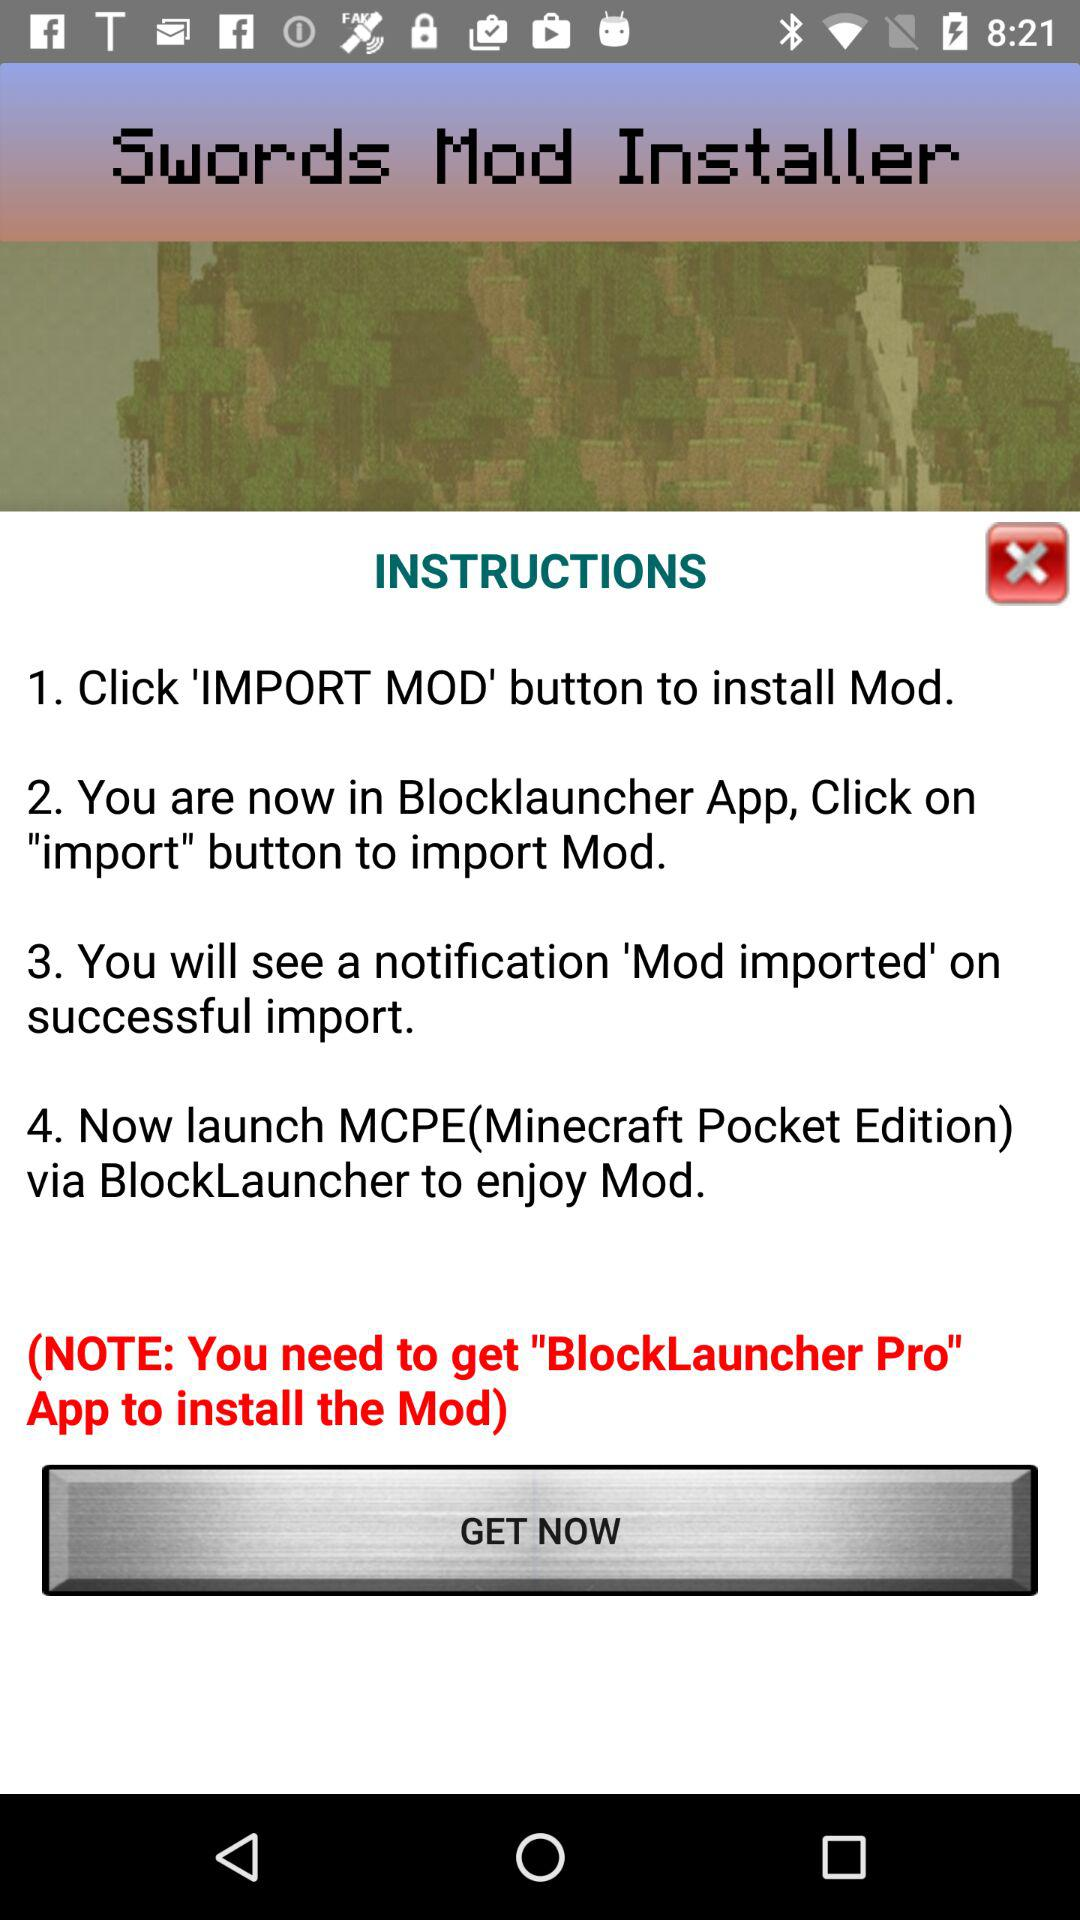Which button should we click to install Mod? You should click the 'IMPORT MOD' button. 